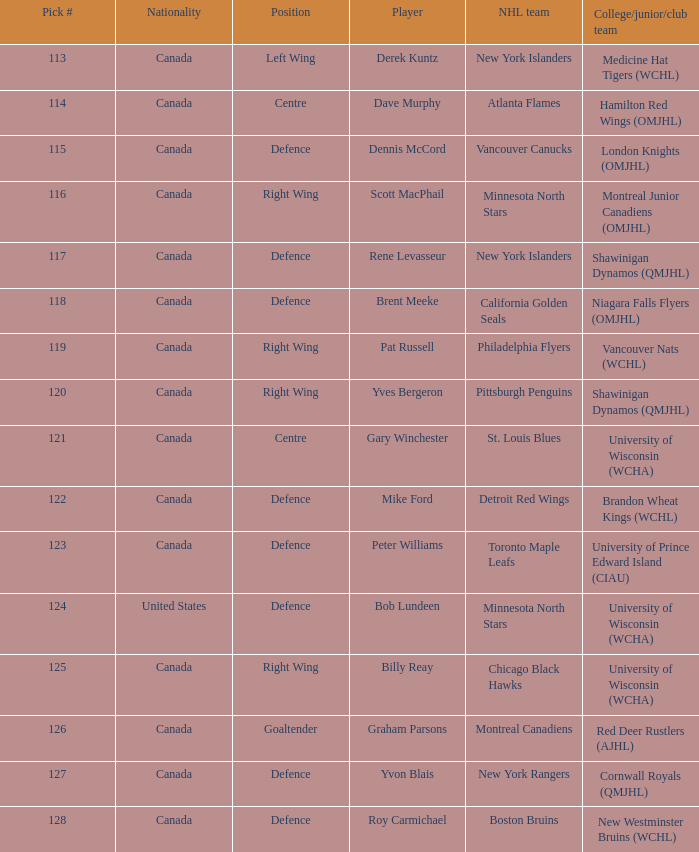Name the player for chicago black hawks Billy Reay. 